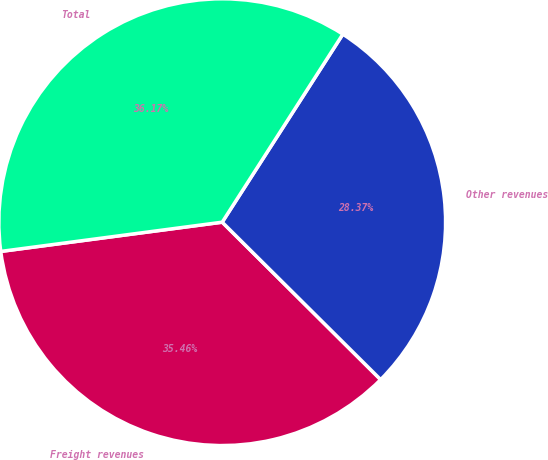Convert chart. <chart><loc_0><loc_0><loc_500><loc_500><pie_chart><fcel>Freight revenues<fcel>Other revenues<fcel>Total<nl><fcel>35.46%<fcel>28.37%<fcel>36.17%<nl></chart> 